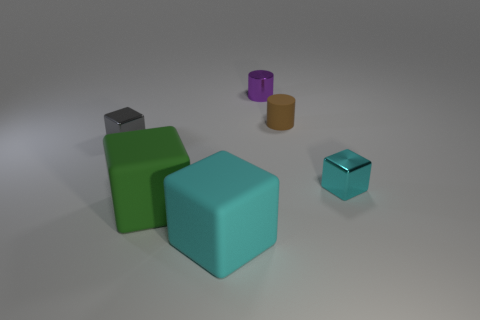How many big objects are made of the same material as the small purple cylinder?
Make the answer very short. 0. What is the shape of the tiny thing that is behind the small brown thing?
Ensure brevity in your answer.  Cylinder. Does the small gray block have the same material as the cyan block that is in front of the large green matte cube?
Offer a terse response. No. Are any small red cylinders visible?
Your response must be concise. No. Are there any cyan matte objects that are to the right of the shiny block to the right of the small brown rubber thing behind the big cyan matte object?
Offer a terse response. No. How many large things are either metallic spheres or purple cylinders?
Make the answer very short. 0. What color is the matte cylinder that is the same size as the gray metal block?
Offer a very short reply. Brown. How many big matte things are in front of the purple object?
Your answer should be very brief. 2. Is there a small purple cylinder that has the same material as the tiny cyan block?
Ensure brevity in your answer.  Yes. What is the color of the small cube that is on the right side of the tiny purple metallic cylinder?
Offer a terse response. Cyan. 